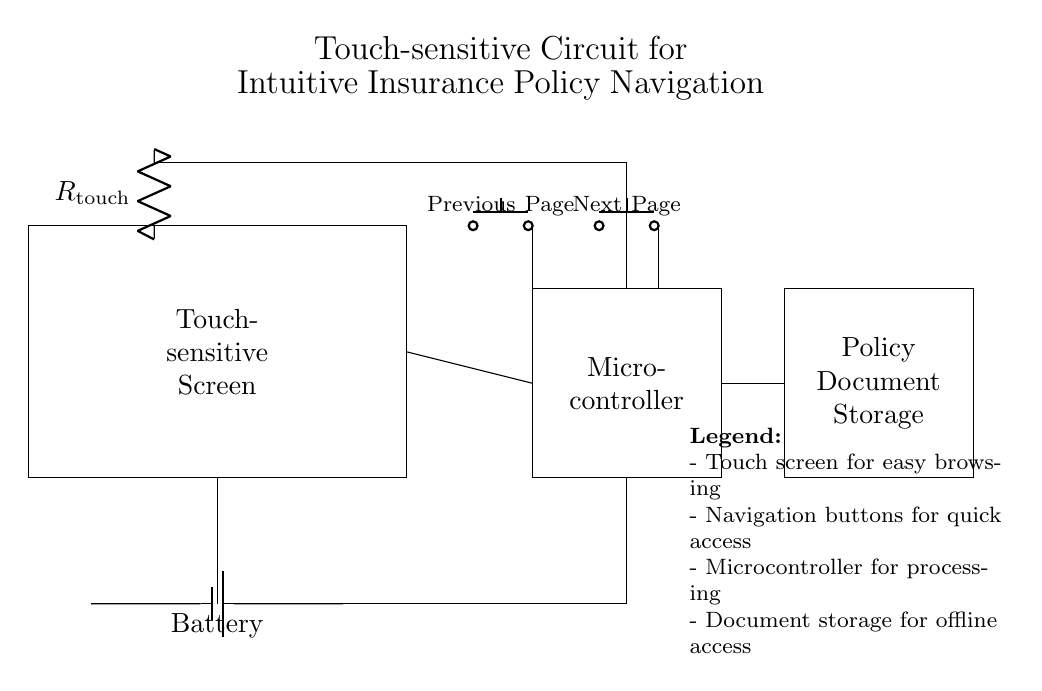What type of screen is used in this circuit? The circuit diagram shows a touch-sensitive screen, indicated by the rectangle and the label "Touch-sensitive Screen." This component serves as the primary interface for navigation.
Answer: Touch-sensitive screen What is the function of the microcontroller in this circuit? The microcontroller processes input from the touch-sensitive screen and navigation buttons, coordinating the interaction with the policy document storage. This is indicated by its label and placement in the circuit.
Answer: Processing How many navigation buttons are present in the circuit? The diagram clearly depicts two navigation buttons, labeled "Previous Page" and "Next Page," located above the microcontroller.
Answer: Two What is the resistance symbol in the circuit? The resistance is symbolized by "R" in the diagram, specifically labeled as "R_touch" next to the component. It indicates the presence of a resistive touch sensor used in the touch screen.
Answer: R_touch What type of storage is indicated in the circuit? The circuit shows a rectangular component labeled "Policy Document Storage," indicating that this part stores the insurance documents for offline access.
Answer: Policy Document Storage How does the battery connect to the circuit components? The battery is depicted at the bottom, with connections running directly to the microcontroller and the resistive touch sensor, representing the power supply to the entire circuit.
Answer: Directly What is the primary navigation function provided by the buttons? The buttons allow users to navigate through insurance policy documents by providing a simple interface to move to the "Previous Page" or "Next Page." This function is essential for intuitive browsing.
Answer: Navigation 